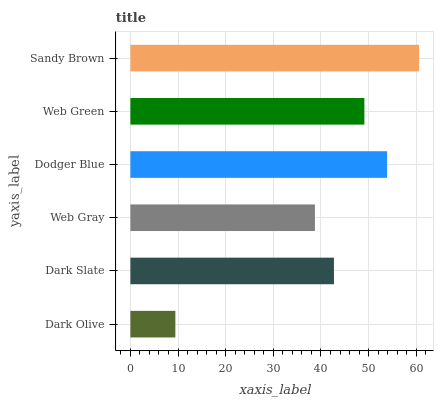Is Dark Olive the minimum?
Answer yes or no. Yes. Is Sandy Brown the maximum?
Answer yes or no. Yes. Is Dark Slate the minimum?
Answer yes or no. No. Is Dark Slate the maximum?
Answer yes or no. No. Is Dark Slate greater than Dark Olive?
Answer yes or no. Yes. Is Dark Olive less than Dark Slate?
Answer yes or no. Yes. Is Dark Olive greater than Dark Slate?
Answer yes or no. No. Is Dark Slate less than Dark Olive?
Answer yes or no. No. Is Web Green the high median?
Answer yes or no. Yes. Is Dark Slate the low median?
Answer yes or no. Yes. Is Sandy Brown the high median?
Answer yes or no. No. Is Sandy Brown the low median?
Answer yes or no. No. 